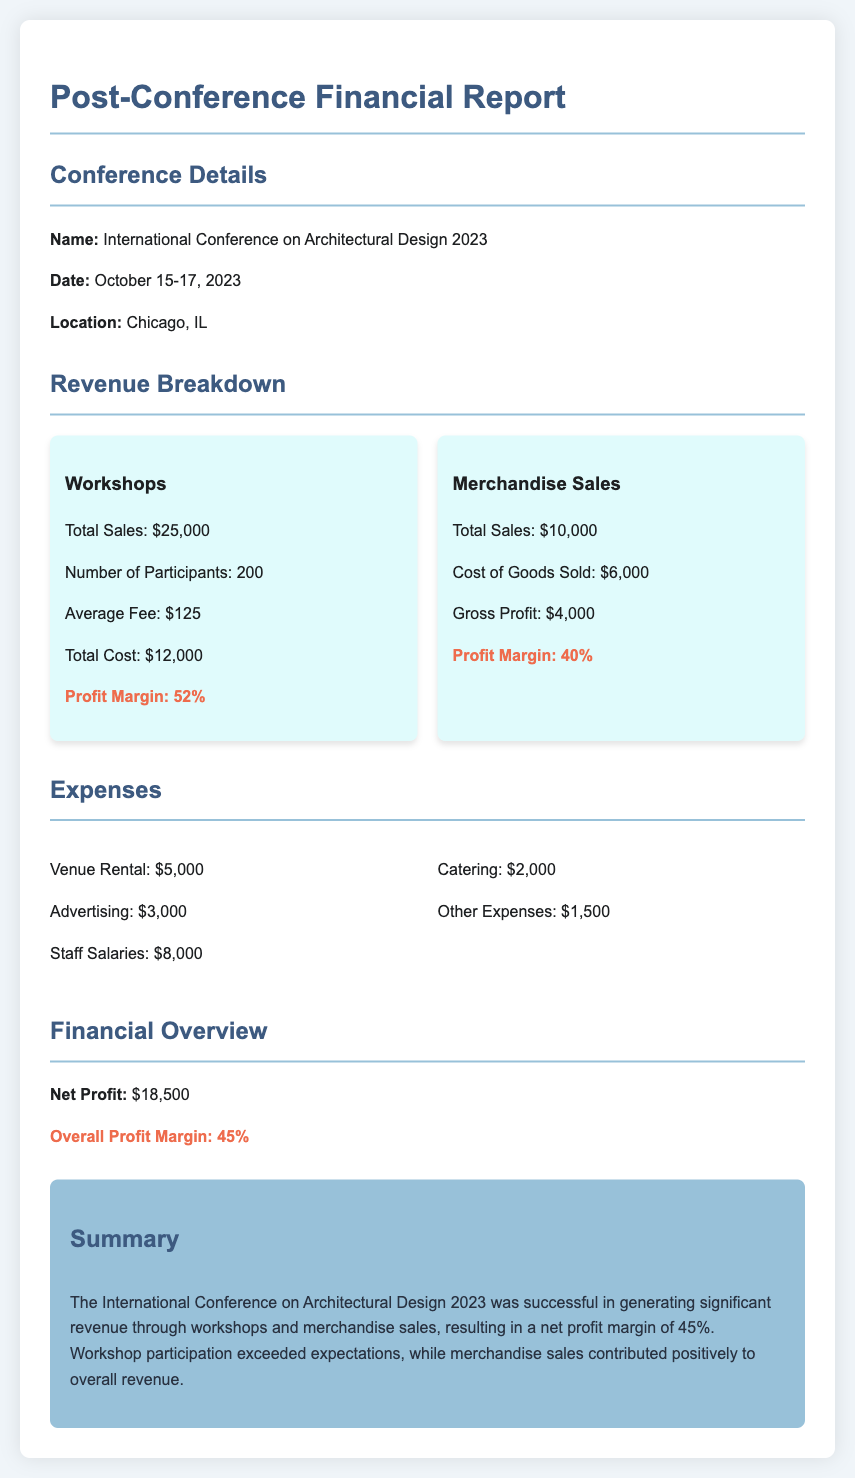What was the total sales from workshops? The total sales from workshops are specifically mentioned in the document, which is $25,000.
Answer: $25,000 What was the total profit margin from merchandise sales? The document provides the profit margin from merchandise sales as 40%.
Answer: 40% How many participants attended the workshops? The document states the number of participants for workshops as 200.
Answer: 200 What was the overall profit margin for the conference? The overall profit margin for the conference is highlighted in the financial overview as 45%.
Answer: 45% What was the total cost of workshops? The total cost of workshops is detailed in the document, which is $12,000.
Answer: $12,000 What were the total expenses for venue rental and advertising? Venue rental is $5,000 and advertising is $3,000; their sum provides the needed information.
Answer: $8,000 What was the net profit generated from the conference? The net profit from the conference is specified in the financial overview as $18,500.
Answer: $18,500 What was the gross profit from merchandise sales? The document indicates that the gross profit from merchandise sales is $4,000.
Answer: $4,000 How much were the total sales from merchandise? The total sales from merchandise are defined in the report, which is $10,000.
Answer: $10,000 